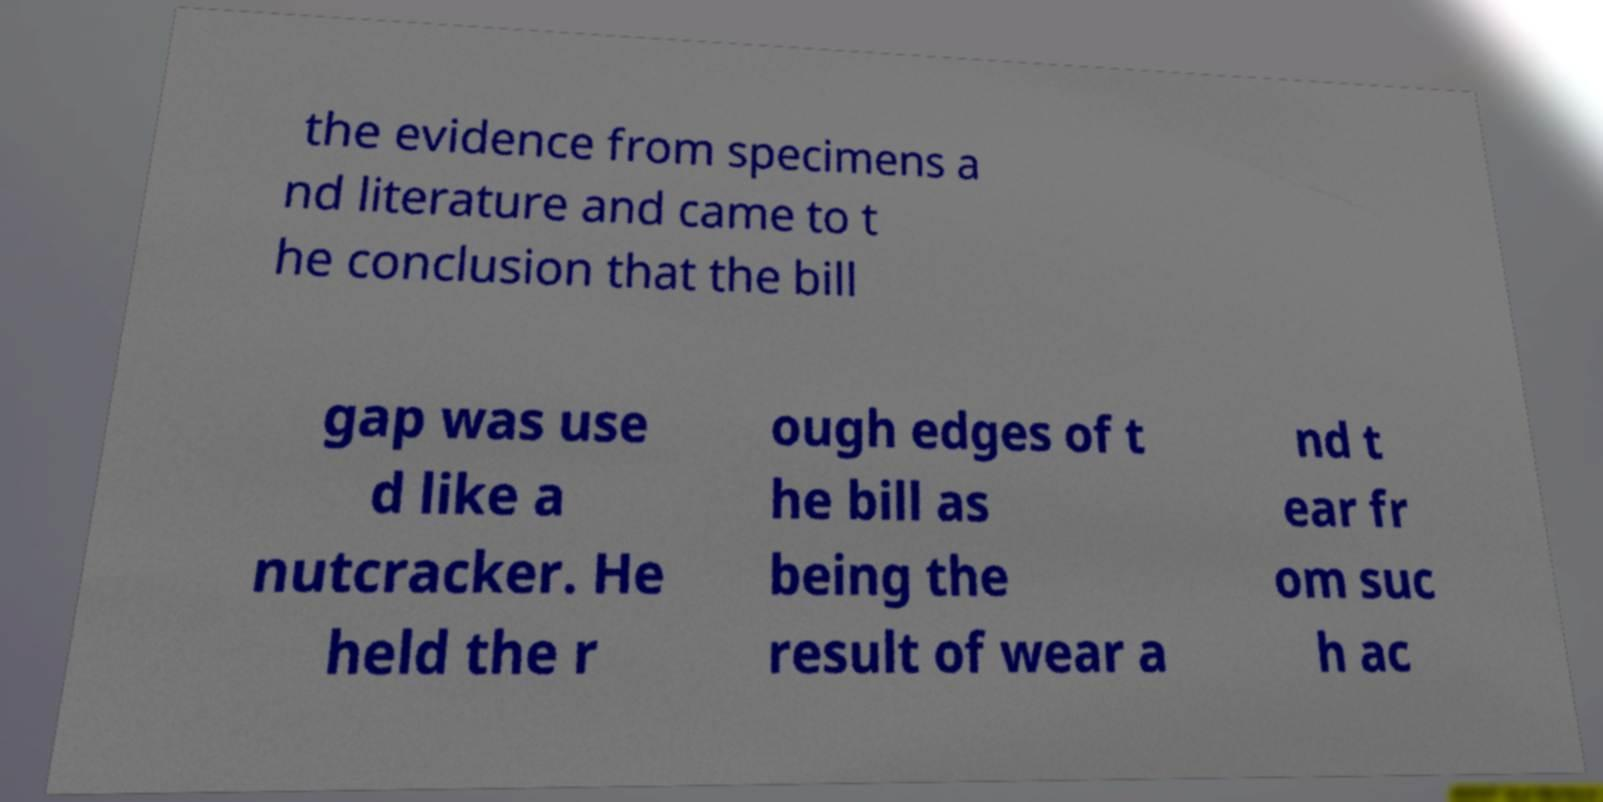Please identify and transcribe the text found in this image. the evidence from specimens a nd literature and came to t he conclusion that the bill gap was use d like a nutcracker. He held the r ough edges of t he bill as being the result of wear a nd t ear fr om suc h ac 